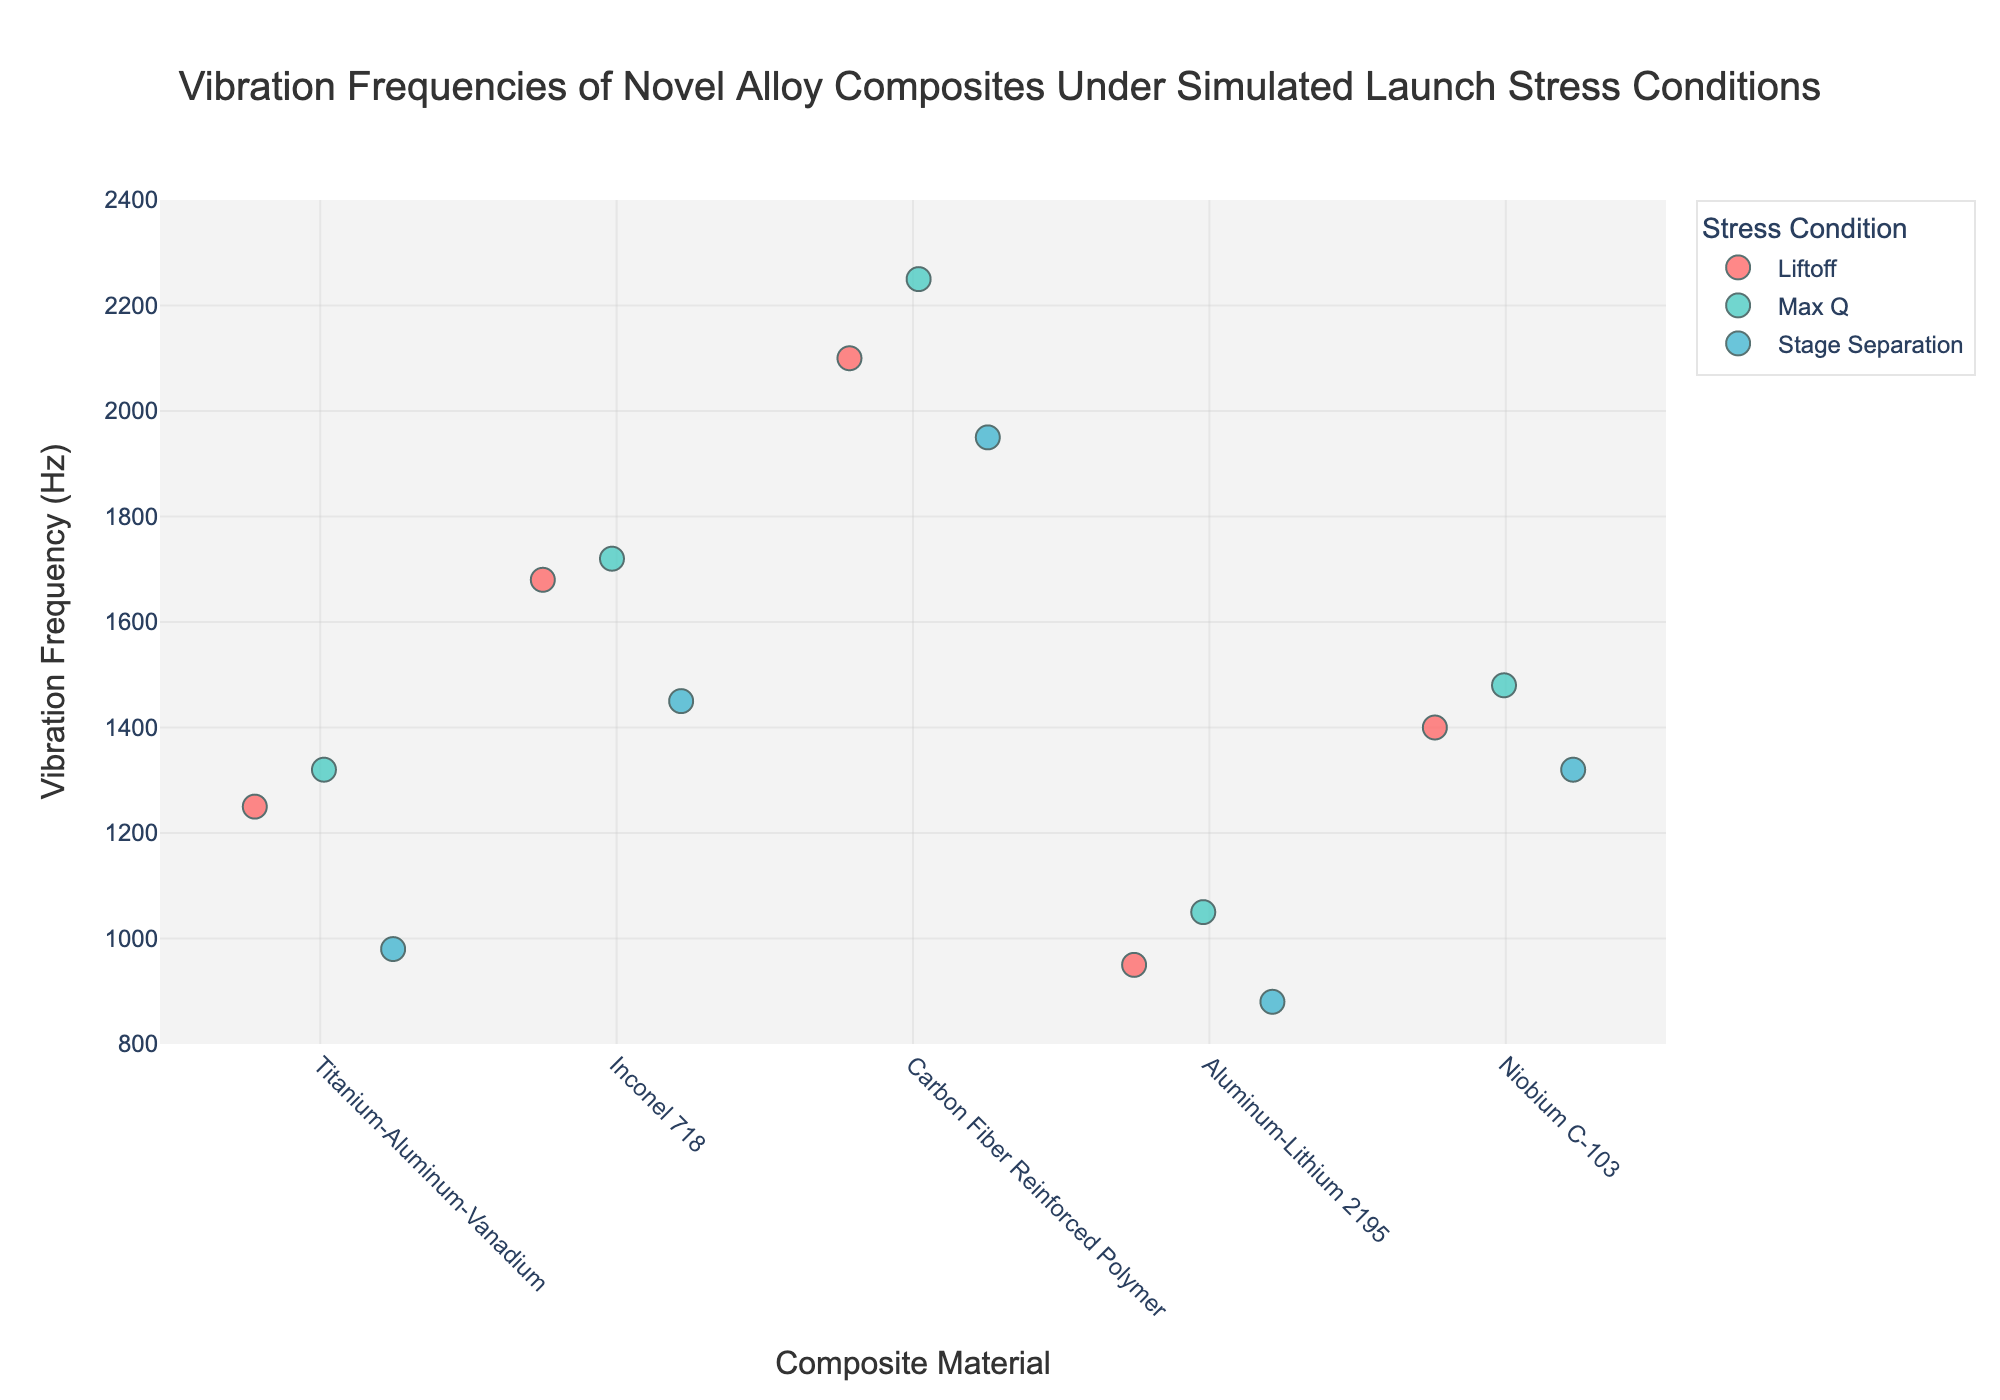What's the title of the figure? The title is shown at the top of the figure. It is a direct description of the data being plotted. "Vibration Frequencies of Novel Alloy Composites Under Simulated Launch Stress Conditions" is the title.
Answer: Vibration Frequencies of Novel Alloy Composites Under Simulated Launch Stress Conditions Which composite material demonstrates the highest vibration frequency under 'Max Q' conditions? Look at the data points under 'Max Q' conditions for all materials and identify the one with the highest frequency value. Carbon Fiber Reinforced Polymer at 2250 Hz has the highest vibration frequency.
Answer: Carbon Fiber Reinforced Polymer What is the range of vibration frequencies displayed in the plot? Identify the minimum and maximum values of the vibration frequencies from the y-axis. The minimum is 880 Hz (Aluminum-Lithium 2195 at Stage Separation) and the maximum is 2250 Hz (Carbon Fiber Reinforced Polymer at Max Q). The range is from 880 Hz to 2250 Hz.
Answer: 880 Hz to 2250 Hz How does the vibration frequency of Inconel 718 under Liftoff conditions compare to that of Aluminum-Lithium 2195 under Stage Separation? Look at the vibration frequencies of Inconel 718 under Liftoff which is 1680 Hz and Aluminum-Lithium 2195 under Stage Separation which is 880 Hz. 1680 Hz is much higher than 880 Hz.
Answer: Higher Which material shows the smallest variation in vibration frequencies across different stress conditions? Calculate the difference between the highest and lowest frequency values for each material and compare them. Titanium-Aluminum-Vanadium ranges from 980 to 1320 Hz, Inconel 718 ranges from 1450 to 1720 Hz, Carbon Fiber Reinforced Polymer ranges from 1950 to 2250 Hz, Aluminum-Lithium 2195 ranges from 880 to 1050 Hz, and Niobium C-103 ranges from 1320 to 1480 Hz. The smallest variation is Aluminum-Lithium 2195 with a range of 170 Hz (1050 - 880).
Answer: Aluminum-Lithium 2195 What is the average vibration frequency of Titanium-Aluminum-Vanadium across all stress conditions? Sum the vibration frequencies of Titanium-Aluminum-Vanadium (1250, 1320, 980) and divide by the number of data points (3). (1250 + 1320 + 980) / 3 = 3550 / 3 = 1183.33.
Answer: 1183.33 Hz Under which stress condition do materials generally have the lowest vibration frequencies? Examine the trend of frequency values under each of the stress conditions (Liftoff, Max Q, Stage Separation). Most materials have lower vibration frequencies at Stage Separation.
Answer: Stage Separation How many data points are there for each composite material? Each composite material has three data points, corresponding to Liftoff, Max Q, and Stage Separation conditions.
Answer: 3 What is the median vibration frequency for Carbon Fiber Reinforced Polymer? Order the vibration frequencies for Carbon Fiber Reinforced Polymer (2100, 2250, 1950) and find the middle value. The ordered values are 1950, 2100, 2250, and the median is 2100 Hz.
Answer: 2100 Hz 